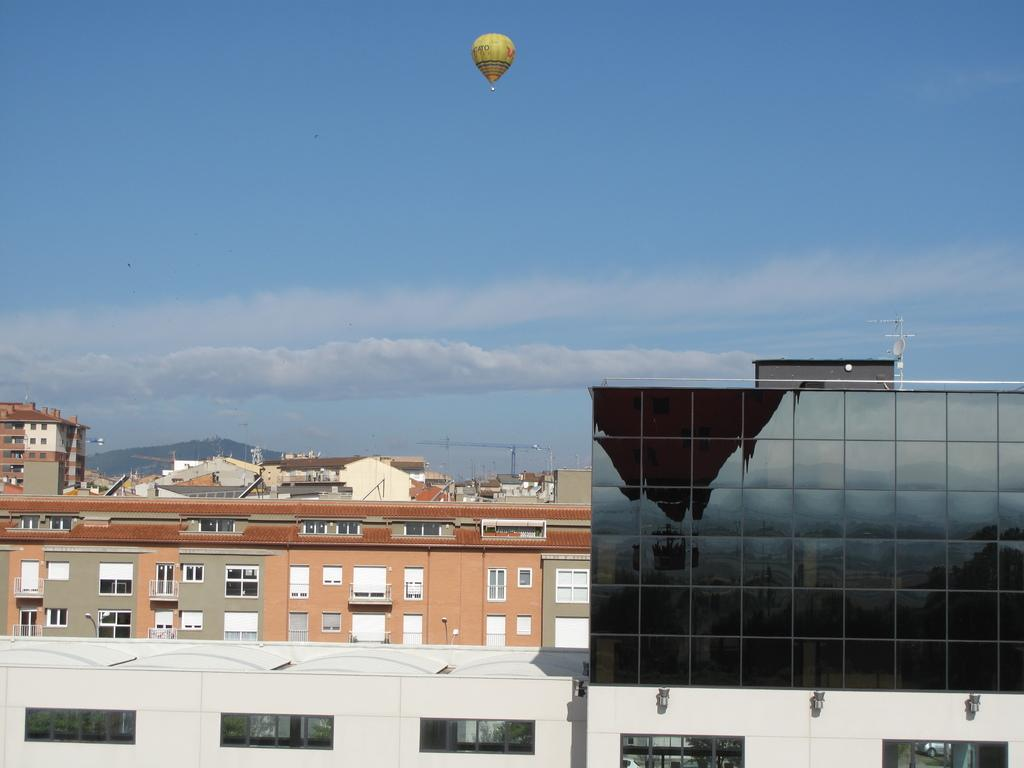What type of structures can be seen in the image? There are buildings in the image. What feature of the buildings is visible in the image? There are windows visible in the image. What is located at the top of the image? There is an air balloon at the top of the image. What is visible in the sky at the top of the image? The sky is visible at the top of the image, and clouds are present in the sky. What statement does the cat make while sitting on the windowsill in the image? There is no cat present in the image, so it cannot make any statements. 